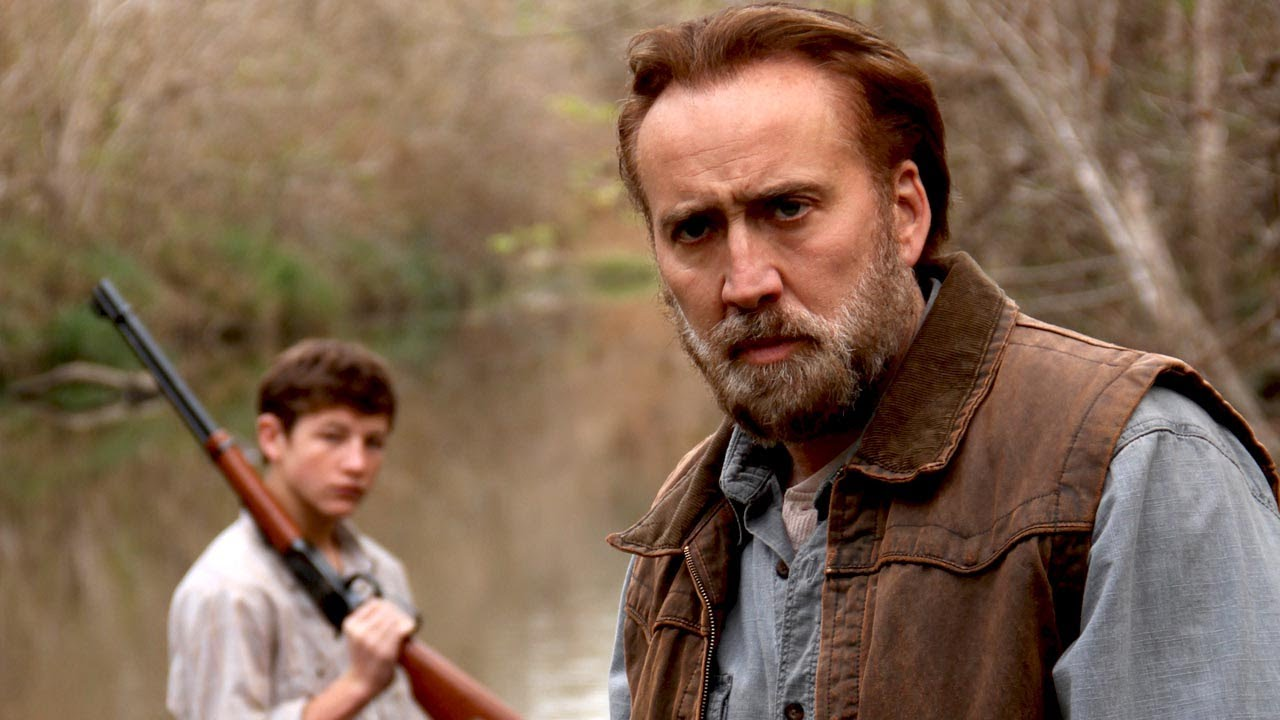Describe the setting where these two characters are. The setting is a lush riverbank with dense, bare trees reflecting in the calm water. The natural surroundings and faded, earthy colors suggest a serene, yet somber mood, typical of rural or wilderness areas. It's a place that seems isolated, emphasizing the solitude and possibly the intensity of the moment shared by the two characters. How does the environment contribute to the image's overall mood? The tranquil yet stark natural environment enhances the solemnity of the scene. The desolate landscape, devoid of other human life and the echo of seasonal change visible in the bare trees, contributes to a mood of introspection, emphasizing the gravity of their activity or the lessons being imparted. It adds a layer of introspective isolation, focusing completely on the interaction between the two characters. 